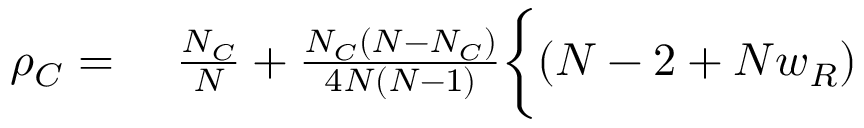<formula> <loc_0><loc_0><loc_500><loc_500>\begin{array} { r l } { \rho _ { C } = } & \frac { N _ { C } } { N } + \frac { N _ { C } ( N - N _ { C } ) } { 4 N ( N - 1 ) } \Big \{ ( N - 2 + N w _ { R } ) } \end{array}</formula> 